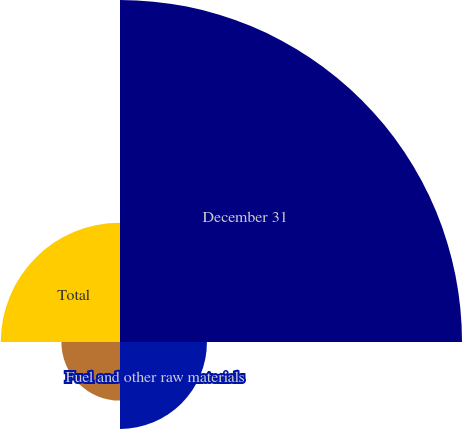Convert chart. <chart><loc_0><loc_0><loc_500><loc_500><pie_chart><fcel>December 31<fcel>Fuel and other raw materials<fcel>Spare parts and supplies<fcel>Total<nl><fcel>56.37%<fcel>14.33%<fcel>9.66%<fcel>19.65%<nl></chart> 